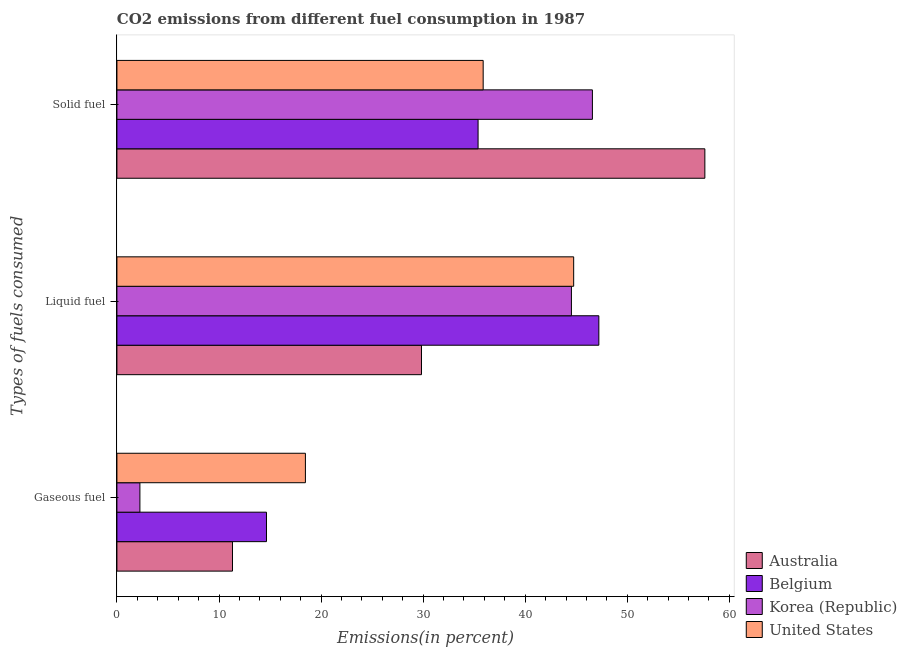How many different coloured bars are there?
Your answer should be very brief. 4. Are the number of bars on each tick of the Y-axis equal?
Keep it short and to the point. Yes. What is the label of the 1st group of bars from the top?
Your response must be concise. Solid fuel. What is the percentage of gaseous fuel emission in Korea (Republic)?
Your answer should be very brief. 2.25. Across all countries, what is the maximum percentage of liquid fuel emission?
Provide a succinct answer. 47.21. Across all countries, what is the minimum percentage of gaseous fuel emission?
Offer a terse response. 2.25. In which country was the percentage of liquid fuel emission minimum?
Keep it short and to the point. Australia. What is the total percentage of gaseous fuel emission in the graph?
Give a very brief answer. 46.69. What is the difference between the percentage of gaseous fuel emission in Australia and that in Korea (Republic)?
Offer a terse response. 9.07. What is the difference between the percentage of gaseous fuel emission in Belgium and the percentage of liquid fuel emission in United States?
Your answer should be compact. -30.1. What is the average percentage of liquid fuel emission per country?
Ensure brevity in your answer.  41.58. What is the difference between the percentage of solid fuel emission and percentage of liquid fuel emission in Belgium?
Make the answer very short. -11.83. In how many countries, is the percentage of solid fuel emission greater than 52 %?
Your answer should be compact. 1. What is the ratio of the percentage of liquid fuel emission in United States to that in Australia?
Make the answer very short. 1.5. Is the percentage of gaseous fuel emission in Belgium less than that in United States?
Make the answer very short. Yes. What is the difference between the highest and the second highest percentage of gaseous fuel emission?
Your response must be concise. 3.81. What is the difference between the highest and the lowest percentage of solid fuel emission?
Keep it short and to the point. 22.22. In how many countries, is the percentage of gaseous fuel emission greater than the average percentage of gaseous fuel emission taken over all countries?
Your response must be concise. 2. What does the 3rd bar from the top in Gaseous fuel represents?
Your answer should be compact. Belgium. Is it the case that in every country, the sum of the percentage of gaseous fuel emission and percentage of liquid fuel emission is greater than the percentage of solid fuel emission?
Provide a succinct answer. No. How many bars are there?
Give a very brief answer. 12. Are the values on the major ticks of X-axis written in scientific E-notation?
Offer a terse response. No. Does the graph contain any zero values?
Your answer should be very brief. No. Where does the legend appear in the graph?
Keep it short and to the point. Bottom right. How are the legend labels stacked?
Your response must be concise. Vertical. What is the title of the graph?
Ensure brevity in your answer.  CO2 emissions from different fuel consumption in 1987. Does "Jamaica" appear as one of the legend labels in the graph?
Provide a succinct answer. No. What is the label or title of the X-axis?
Your response must be concise. Emissions(in percent). What is the label or title of the Y-axis?
Provide a succinct answer. Types of fuels consumed. What is the Emissions(in percent) in Australia in Gaseous fuel?
Provide a short and direct response. 11.32. What is the Emissions(in percent) in Belgium in Gaseous fuel?
Give a very brief answer. 14.65. What is the Emissions(in percent) in Korea (Republic) in Gaseous fuel?
Keep it short and to the point. 2.25. What is the Emissions(in percent) of United States in Gaseous fuel?
Your response must be concise. 18.46. What is the Emissions(in percent) of Australia in Liquid fuel?
Offer a terse response. 29.84. What is the Emissions(in percent) in Belgium in Liquid fuel?
Your answer should be very brief. 47.21. What is the Emissions(in percent) of Korea (Republic) in Liquid fuel?
Offer a terse response. 44.53. What is the Emissions(in percent) in United States in Liquid fuel?
Offer a very short reply. 44.75. What is the Emissions(in percent) in Australia in Solid fuel?
Your response must be concise. 57.6. What is the Emissions(in percent) in Belgium in Solid fuel?
Your response must be concise. 35.38. What is the Emissions(in percent) of Korea (Republic) in Solid fuel?
Provide a short and direct response. 46.58. What is the Emissions(in percent) in United States in Solid fuel?
Provide a succinct answer. 35.88. Across all Types of fuels consumed, what is the maximum Emissions(in percent) of Australia?
Make the answer very short. 57.6. Across all Types of fuels consumed, what is the maximum Emissions(in percent) in Belgium?
Offer a very short reply. 47.21. Across all Types of fuels consumed, what is the maximum Emissions(in percent) of Korea (Republic)?
Offer a very short reply. 46.58. Across all Types of fuels consumed, what is the maximum Emissions(in percent) in United States?
Your response must be concise. 44.75. Across all Types of fuels consumed, what is the minimum Emissions(in percent) of Australia?
Your answer should be very brief. 11.32. Across all Types of fuels consumed, what is the minimum Emissions(in percent) in Belgium?
Ensure brevity in your answer.  14.65. Across all Types of fuels consumed, what is the minimum Emissions(in percent) in Korea (Republic)?
Offer a terse response. 2.25. Across all Types of fuels consumed, what is the minimum Emissions(in percent) of United States?
Ensure brevity in your answer.  18.46. What is the total Emissions(in percent) of Australia in the graph?
Offer a very short reply. 98.76. What is the total Emissions(in percent) in Belgium in the graph?
Give a very brief answer. 97.24. What is the total Emissions(in percent) in Korea (Republic) in the graph?
Your response must be concise. 93.36. What is the total Emissions(in percent) in United States in the graph?
Give a very brief answer. 99.09. What is the difference between the Emissions(in percent) of Australia in Gaseous fuel and that in Liquid fuel?
Provide a succinct answer. -18.51. What is the difference between the Emissions(in percent) in Belgium in Gaseous fuel and that in Liquid fuel?
Provide a succinct answer. -32.56. What is the difference between the Emissions(in percent) in Korea (Republic) in Gaseous fuel and that in Liquid fuel?
Give a very brief answer. -42.27. What is the difference between the Emissions(in percent) in United States in Gaseous fuel and that in Liquid fuel?
Provide a short and direct response. -26.28. What is the difference between the Emissions(in percent) of Australia in Gaseous fuel and that in Solid fuel?
Make the answer very short. -46.28. What is the difference between the Emissions(in percent) in Belgium in Gaseous fuel and that in Solid fuel?
Give a very brief answer. -20.73. What is the difference between the Emissions(in percent) in Korea (Republic) in Gaseous fuel and that in Solid fuel?
Your response must be concise. -44.33. What is the difference between the Emissions(in percent) of United States in Gaseous fuel and that in Solid fuel?
Make the answer very short. -17.42. What is the difference between the Emissions(in percent) of Australia in Liquid fuel and that in Solid fuel?
Your answer should be compact. -27.76. What is the difference between the Emissions(in percent) of Belgium in Liquid fuel and that in Solid fuel?
Provide a succinct answer. 11.83. What is the difference between the Emissions(in percent) of Korea (Republic) in Liquid fuel and that in Solid fuel?
Provide a short and direct response. -2.06. What is the difference between the Emissions(in percent) of United States in Liquid fuel and that in Solid fuel?
Provide a succinct answer. 8.87. What is the difference between the Emissions(in percent) in Australia in Gaseous fuel and the Emissions(in percent) in Belgium in Liquid fuel?
Keep it short and to the point. -35.89. What is the difference between the Emissions(in percent) of Australia in Gaseous fuel and the Emissions(in percent) of Korea (Republic) in Liquid fuel?
Offer a very short reply. -33.2. What is the difference between the Emissions(in percent) of Australia in Gaseous fuel and the Emissions(in percent) of United States in Liquid fuel?
Keep it short and to the point. -33.43. What is the difference between the Emissions(in percent) of Belgium in Gaseous fuel and the Emissions(in percent) of Korea (Republic) in Liquid fuel?
Your answer should be very brief. -29.87. What is the difference between the Emissions(in percent) of Belgium in Gaseous fuel and the Emissions(in percent) of United States in Liquid fuel?
Provide a succinct answer. -30.09. What is the difference between the Emissions(in percent) in Korea (Republic) in Gaseous fuel and the Emissions(in percent) in United States in Liquid fuel?
Provide a short and direct response. -42.49. What is the difference between the Emissions(in percent) in Australia in Gaseous fuel and the Emissions(in percent) in Belgium in Solid fuel?
Ensure brevity in your answer.  -24.06. What is the difference between the Emissions(in percent) of Australia in Gaseous fuel and the Emissions(in percent) of Korea (Republic) in Solid fuel?
Your answer should be very brief. -35.26. What is the difference between the Emissions(in percent) of Australia in Gaseous fuel and the Emissions(in percent) of United States in Solid fuel?
Provide a short and direct response. -24.56. What is the difference between the Emissions(in percent) in Belgium in Gaseous fuel and the Emissions(in percent) in Korea (Republic) in Solid fuel?
Ensure brevity in your answer.  -31.93. What is the difference between the Emissions(in percent) in Belgium in Gaseous fuel and the Emissions(in percent) in United States in Solid fuel?
Ensure brevity in your answer.  -21.23. What is the difference between the Emissions(in percent) of Korea (Republic) in Gaseous fuel and the Emissions(in percent) of United States in Solid fuel?
Provide a succinct answer. -33.63. What is the difference between the Emissions(in percent) of Australia in Liquid fuel and the Emissions(in percent) of Belgium in Solid fuel?
Offer a very short reply. -5.54. What is the difference between the Emissions(in percent) of Australia in Liquid fuel and the Emissions(in percent) of Korea (Republic) in Solid fuel?
Ensure brevity in your answer.  -16.74. What is the difference between the Emissions(in percent) in Australia in Liquid fuel and the Emissions(in percent) in United States in Solid fuel?
Ensure brevity in your answer.  -6.04. What is the difference between the Emissions(in percent) in Belgium in Liquid fuel and the Emissions(in percent) in Korea (Republic) in Solid fuel?
Keep it short and to the point. 0.63. What is the difference between the Emissions(in percent) in Belgium in Liquid fuel and the Emissions(in percent) in United States in Solid fuel?
Offer a very short reply. 11.33. What is the difference between the Emissions(in percent) of Korea (Republic) in Liquid fuel and the Emissions(in percent) of United States in Solid fuel?
Provide a succinct answer. 8.64. What is the average Emissions(in percent) in Australia per Types of fuels consumed?
Offer a terse response. 32.92. What is the average Emissions(in percent) in Belgium per Types of fuels consumed?
Make the answer very short. 32.41. What is the average Emissions(in percent) in Korea (Republic) per Types of fuels consumed?
Offer a terse response. 31.12. What is the average Emissions(in percent) in United States per Types of fuels consumed?
Keep it short and to the point. 33.03. What is the difference between the Emissions(in percent) in Australia and Emissions(in percent) in Belgium in Gaseous fuel?
Your response must be concise. -3.33. What is the difference between the Emissions(in percent) of Australia and Emissions(in percent) of Korea (Republic) in Gaseous fuel?
Provide a succinct answer. 9.07. What is the difference between the Emissions(in percent) of Australia and Emissions(in percent) of United States in Gaseous fuel?
Ensure brevity in your answer.  -7.14. What is the difference between the Emissions(in percent) in Belgium and Emissions(in percent) in Korea (Republic) in Gaseous fuel?
Provide a succinct answer. 12.4. What is the difference between the Emissions(in percent) of Belgium and Emissions(in percent) of United States in Gaseous fuel?
Give a very brief answer. -3.81. What is the difference between the Emissions(in percent) of Korea (Republic) and Emissions(in percent) of United States in Gaseous fuel?
Your answer should be compact. -16.21. What is the difference between the Emissions(in percent) in Australia and Emissions(in percent) in Belgium in Liquid fuel?
Offer a very short reply. -17.38. What is the difference between the Emissions(in percent) of Australia and Emissions(in percent) of Korea (Republic) in Liquid fuel?
Make the answer very short. -14.69. What is the difference between the Emissions(in percent) of Australia and Emissions(in percent) of United States in Liquid fuel?
Keep it short and to the point. -14.91. What is the difference between the Emissions(in percent) of Belgium and Emissions(in percent) of Korea (Republic) in Liquid fuel?
Offer a terse response. 2.69. What is the difference between the Emissions(in percent) in Belgium and Emissions(in percent) in United States in Liquid fuel?
Your answer should be compact. 2.47. What is the difference between the Emissions(in percent) in Korea (Republic) and Emissions(in percent) in United States in Liquid fuel?
Keep it short and to the point. -0.22. What is the difference between the Emissions(in percent) of Australia and Emissions(in percent) of Belgium in Solid fuel?
Keep it short and to the point. 22.22. What is the difference between the Emissions(in percent) in Australia and Emissions(in percent) in Korea (Republic) in Solid fuel?
Your response must be concise. 11.02. What is the difference between the Emissions(in percent) of Australia and Emissions(in percent) of United States in Solid fuel?
Give a very brief answer. 21.72. What is the difference between the Emissions(in percent) in Belgium and Emissions(in percent) in Korea (Republic) in Solid fuel?
Provide a succinct answer. -11.2. What is the difference between the Emissions(in percent) of Belgium and Emissions(in percent) of United States in Solid fuel?
Your response must be concise. -0.5. What is the difference between the Emissions(in percent) of Korea (Republic) and Emissions(in percent) of United States in Solid fuel?
Keep it short and to the point. 10.7. What is the ratio of the Emissions(in percent) of Australia in Gaseous fuel to that in Liquid fuel?
Offer a terse response. 0.38. What is the ratio of the Emissions(in percent) of Belgium in Gaseous fuel to that in Liquid fuel?
Keep it short and to the point. 0.31. What is the ratio of the Emissions(in percent) of Korea (Republic) in Gaseous fuel to that in Liquid fuel?
Give a very brief answer. 0.05. What is the ratio of the Emissions(in percent) of United States in Gaseous fuel to that in Liquid fuel?
Your response must be concise. 0.41. What is the ratio of the Emissions(in percent) of Australia in Gaseous fuel to that in Solid fuel?
Offer a terse response. 0.2. What is the ratio of the Emissions(in percent) of Belgium in Gaseous fuel to that in Solid fuel?
Provide a succinct answer. 0.41. What is the ratio of the Emissions(in percent) in Korea (Republic) in Gaseous fuel to that in Solid fuel?
Provide a succinct answer. 0.05. What is the ratio of the Emissions(in percent) in United States in Gaseous fuel to that in Solid fuel?
Your answer should be very brief. 0.51. What is the ratio of the Emissions(in percent) of Australia in Liquid fuel to that in Solid fuel?
Your answer should be very brief. 0.52. What is the ratio of the Emissions(in percent) in Belgium in Liquid fuel to that in Solid fuel?
Keep it short and to the point. 1.33. What is the ratio of the Emissions(in percent) of Korea (Republic) in Liquid fuel to that in Solid fuel?
Give a very brief answer. 0.96. What is the ratio of the Emissions(in percent) of United States in Liquid fuel to that in Solid fuel?
Offer a terse response. 1.25. What is the difference between the highest and the second highest Emissions(in percent) of Australia?
Keep it short and to the point. 27.76. What is the difference between the highest and the second highest Emissions(in percent) of Belgium?
Offer a terse response. 11.83. What is the difference between the highest and the second highest Emissions(in percent) of Korea (Republic)?
Offer a terse response. 2.06. What is the difference between the highest and the second highest Emissions(in percent) of United States?
Give a very brief answer. 8.87. What is the difference between the highest and the lowest Emissions(in percent) of Australia?
Offer a very short reply. 46.28. What is the difference between the highest and the lowest Emissions(in percent) in Belgium?
Keep it short and to the point. 32.56. What is the difference between the highest and the lowest Emissions(in percent) of Korea (Republic)?
Your answer should be very brief. 44.33. What is the difference between the highest and the lowest Emissions(in percent) of United States?
Provide a succinct answer. 26.28. 